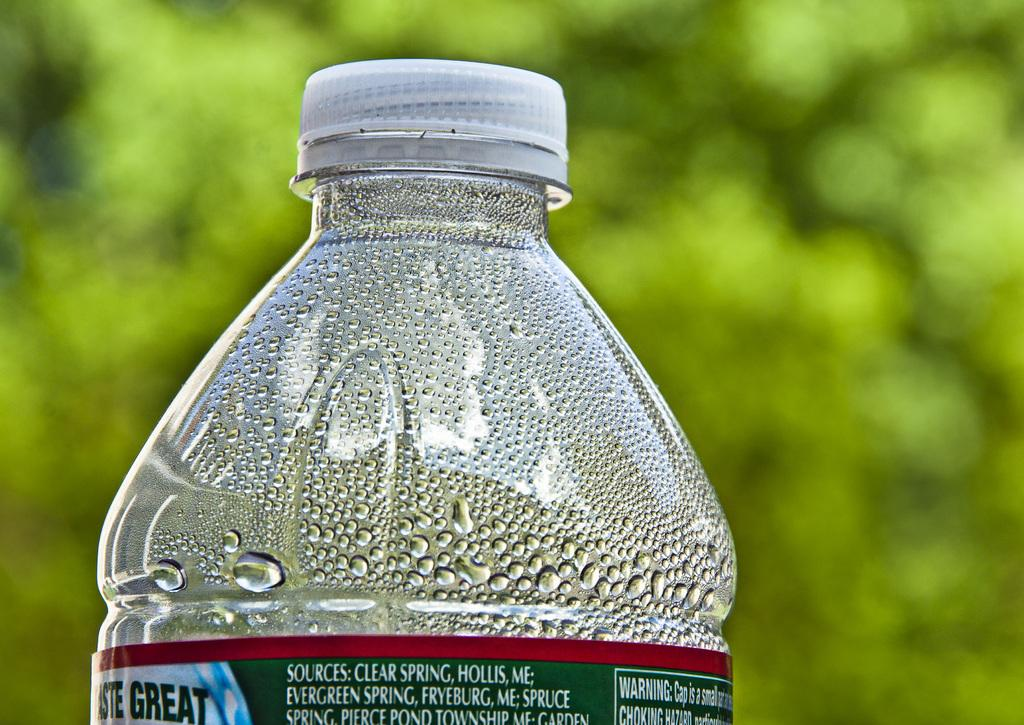<image>
Share a concise interpretation of the image provided. The condensation collected in the top of a bottle of water from Clear Spring, Hollis ME. 